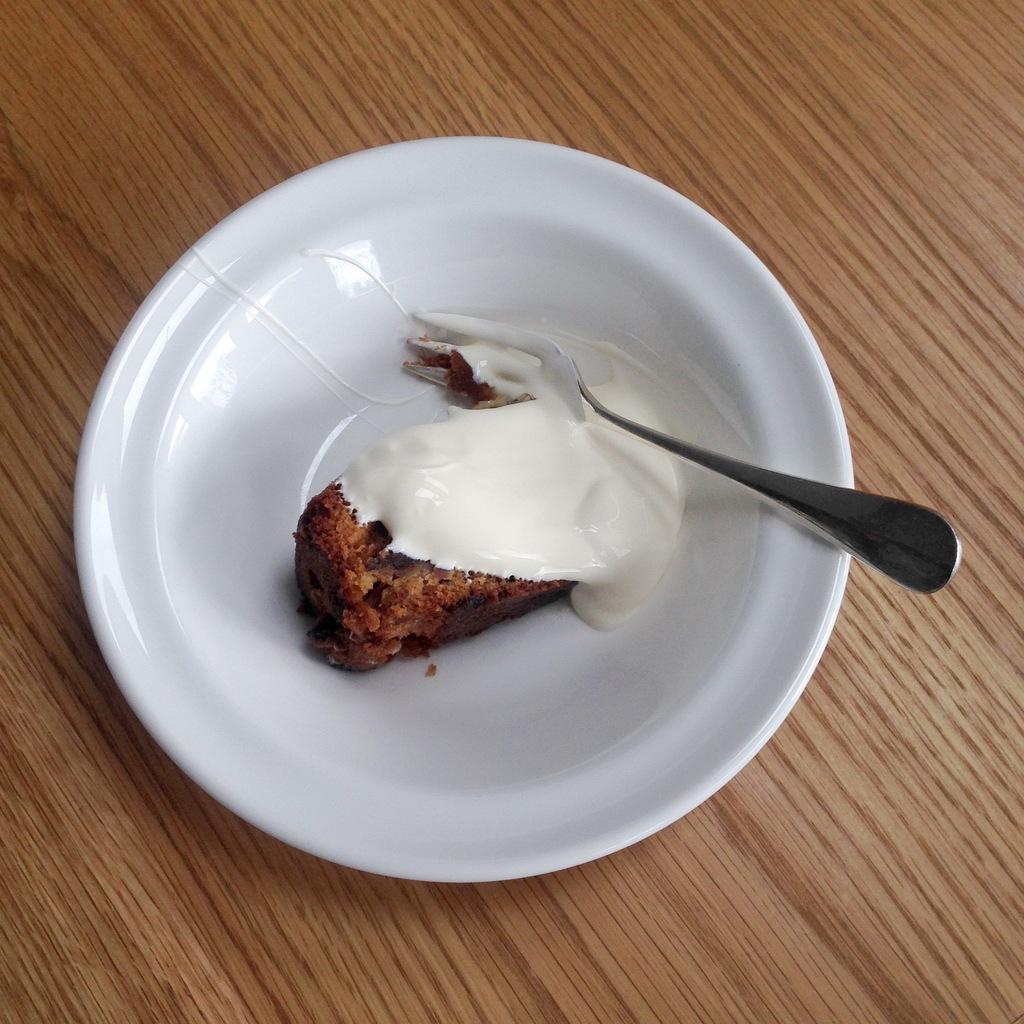How would you summarize this image in a sentence or two? In this image we can see a plate containing dessert and a fork placed on the table. 